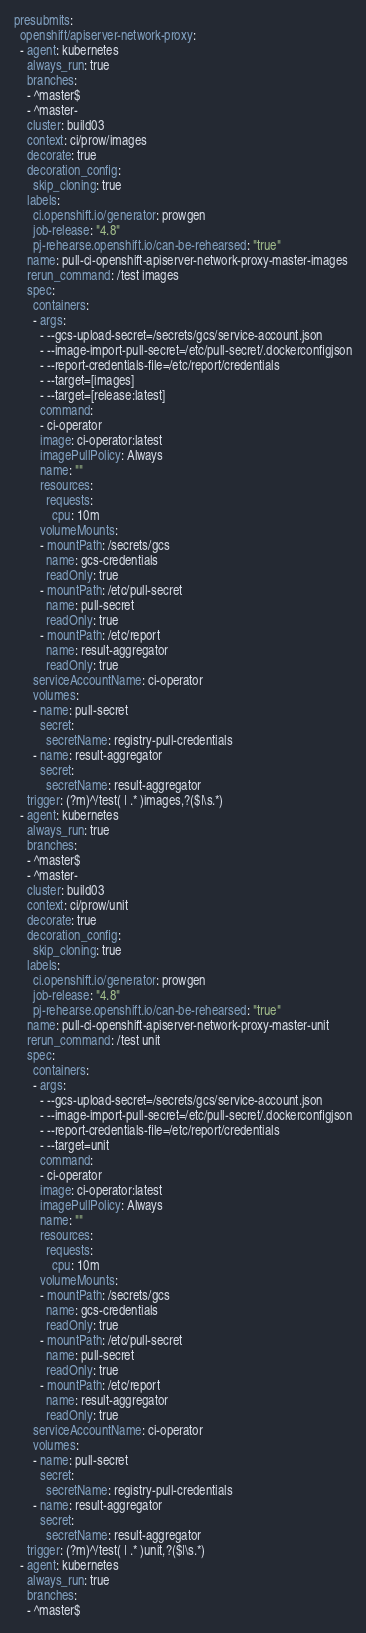<code> <loc_0><loc_0><loc_500><loc_500><_YAML_>presubmits:
  openshift/apiserver-network-proxy:
  - agent: kubernetes
    always_run: true
    branches:
    - ^master$
    - ^master-
    cluster: build03
    context: ci/prow/images
    decorate: true
    decoration_config:
      skip_cloning: true
    labels:
      ci.openshift.io/generator: prowgen
      job-release: "4.8"
      pj-rehearse.openshift.io/can-be-rehearsed: "true"
    name: pull-ci-openshift-apiserver-network-proxy-master-images
    rerun_command: /test images
    spec:
      containers:
      - args:
        - --gcs-upload-secret=/secrets/gcs/service-account.json
        - --image-import-pull-secret=/etc/pull-secret/.dockerconfigjson
        - --report-credentials-file=/etc/report/credentials
        - --target=[images]
        - --target=[release:latest]
        command:
        - ci-operator
        image: ci-operator:latest
        imagePullPolicy: Always
        name: ""
        resources:
          requests:
            cpu: 10m
        volumeMounts:
        - mountPath: /secrets/gcs
          name: gcs-credentials
          readOnly: true
        - mountPath: /etc/pull-secret
          name: pull-secret
          readOnly: true
        - mountPath: /etc/report
          name: result-aggregator
          readOnly: true
      serviceAccountName: ci-operator
      volumes:
      - name: pull-secret
        secret:
          secretName: registry-pull-credentials
      - name: result-aggregator
        secret:
          secretName: result-aggregator
    trigger: (?m)^/test( | .* )images,?($|\s.*)
  - agent: kubernetes
    always_run: true
    branches:
    - ^master$
    - ^master-
    cluster: build03
    context: ci/prow/unit
    decorate: true
    decoration_config:
      skip_cloning: true
    labels:
      ci.openshift.io/generator: prowgen
      job-release: "4.8"
      pj-rehearse.openshift.io/can-be-rehearsed: "true"
    name: pull-ci-openshift-apiserver-network-proxy-master-unit
    rerun_command: /test unit
    spec:
      containers:
      - args:
        - --gcs-upload-secret=/secrets/gcs/service-account.json
        - --image-import-pull-secret=/etc/pull-secret/.dockerconfigjson
        - --report-credentials-file=/etc/report/credentials
        - --target=unit
        command:
        - ci-operator
        image: ci-operator:latest
        imagePullPolicy: Always
        name: ""
        resources:
          requests:
            cpu: 10m
        volumeMounts:
        - mountPath: /secrets/gcs
          name: gcs-credentials
          readOnly: true
        - mountPath: /etc/pull-secret
          name: pull-secret
          readOnly: true
        - mountPath: /etc/report
          name: result-aggregator
          readOnly: true
      serviceAccountName: ci-operator
      volumes:
      - name: pull-secret
        secret:
          secretName: registry-pull-credentials
      - name: result-aggregator
        secret:
          secretName: result-aggregator
    trigger: (?m)^/test( | .* )unit,?($|\s.*)
  - agent: kubernetes
    always_run: true
    branches:
    - ^master$</code> 